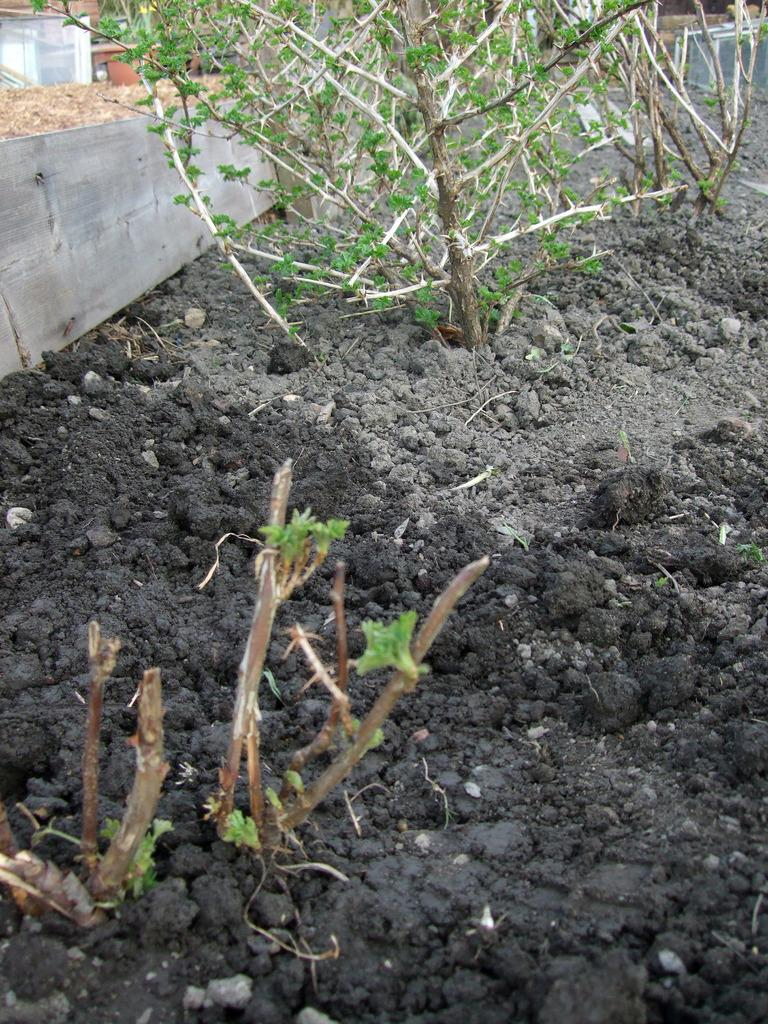What type of living organisms can be seen in the image? Plants can be seen in the image. Where are the plants located in the image? The plants are on the ground in the image. What object can be seen on the left side of the image? There is an object that looks like a wooden plank on the left side of the image. What type of airport can be seen in the image? There is no airport present in the image; it features plants on the ground and a wooden plank object. What suggestion is being made by the plants in the image? The plants in the image are not making any suggestions, as they are inanimate objects. 